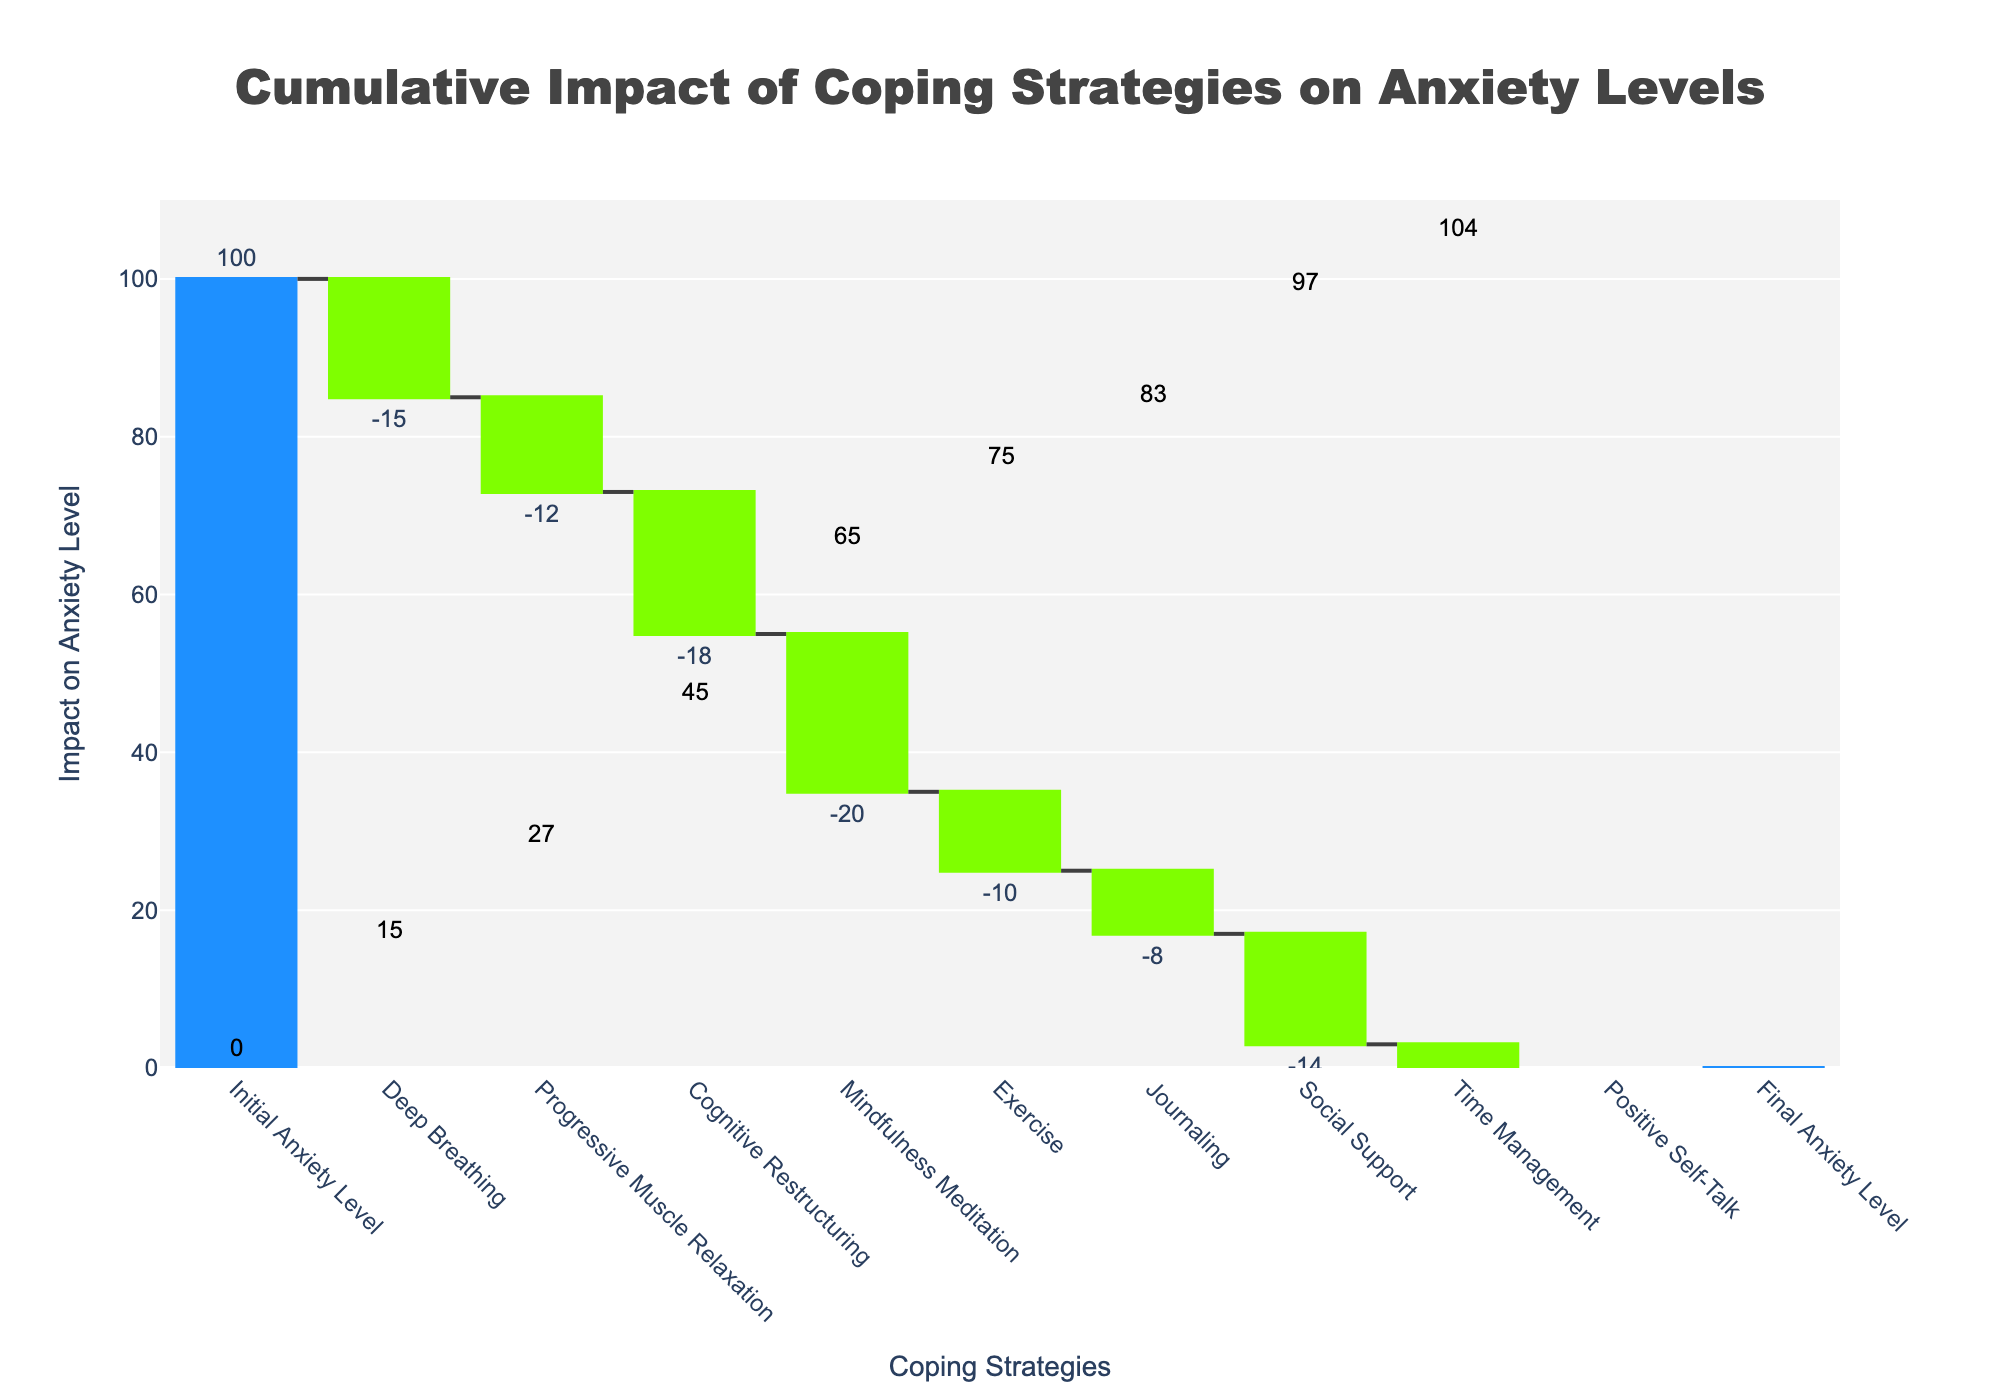What is the title of the Waterfall Chart? The title is displayed at the top of the chart, typically in a larger and bold font to indicate the main topic of the visual presentation. The title reads "Cumulative Impact of Coping Strategies on Anxiety Levels".
Answer: Cumulative Impact of Coping Strategies on Anxiety Levels How many coping strategies are displayed in the chart? Count the number of bars labeled for coping strategies in the x-axis. There should be nine coping strategies along with the initial and final anxiety level bars.
Answer: 9 What is the initial level of anxiety before any coping strategies are applied? The initial level of anxiety is shown at the beginning of the chart, indicated by the first bar labeled "Initial Anxiety Level". The bar reaches the 100 mark on the y-axis.
Answer: 100 Which coping strategy has the largest individual impact on reducing anxiety? Examine the lengths of the bars that show decreases (green bars) for each coping strategy. The bar that extends furthest down represents "Mindfulness Meditation" with an impact of -20.
Answer: Mindfulness Meditation What is the cumulative anxiety level after applying Progressive Muscle Relaxation and Cognitive Restructuring? Sum the impacts of Progressive Muscle Relaxation (-12) and Cognitive Restructuring (-18) sequentially from the initial level (100). The cumulative impact is 100 - 12 - 18 = 70.
Answer: 70 Which coping strategy has the smallest impact on reducing anxiety? Look at the bars with the least amount of downward movement (green bars) and identify the strategy. "Time Management" reduces anxiety by -7, which is the smallest reduction among the strategies.
Answer: Time Management What is the final anxiety level after applying all the coping strategies? Refer to the final bar labeled "Final Anxiety Level". The bar is at the level 0 on the y-axis, indicating no anxiety level remaining.
Answer: 0 By how much does "Exercise" reduce anxiety? Find the bar labeled "Exercise" and observe its impact value, which is displayed outside the bar. The impact value is -10.
Answer: 10 Compare the impact of "Journaling" and "Social Support". Which one has a greater impact? Look at the individual impact values for both strategies. "Journaling" has an impact of -8 while "Social Support" has an impact of -14. Since -14 is a larger absolute value, "Social Support" has the greater impact.
Answer: Social Support What is the total reduction in anxiety levels due to all the coping strategies combined? Calculate the sum of all the individual impacts of the coping strategies. Summing up these negative impacts (-15, -12, -18, -20, -10, -8, -14, -7, -11) gives a total reduction of -115.
Answer: -115 